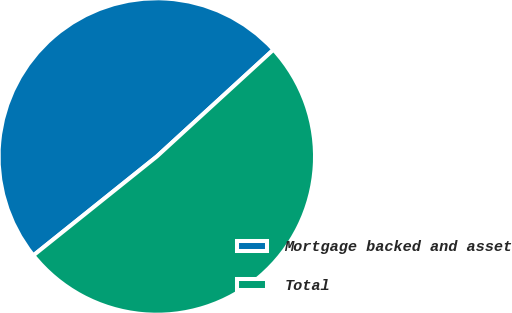Convert chart. <chart><loc_0><loc_0><loc_500><loc_500><pie_chart><fcel>Mortgage backed and asset<fcel>Total<nl><fcel>48.95%<fcel>51.05%<nl></chart> 